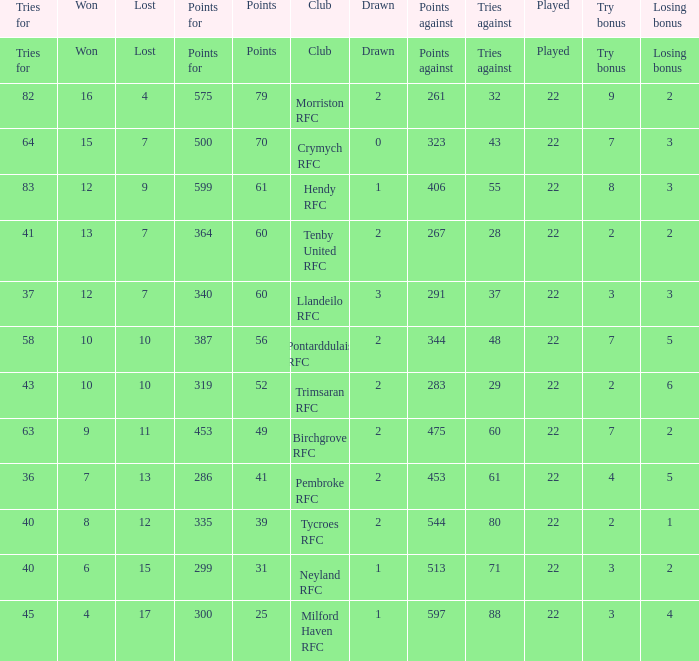What's the points with tries for being 64 70.0. 